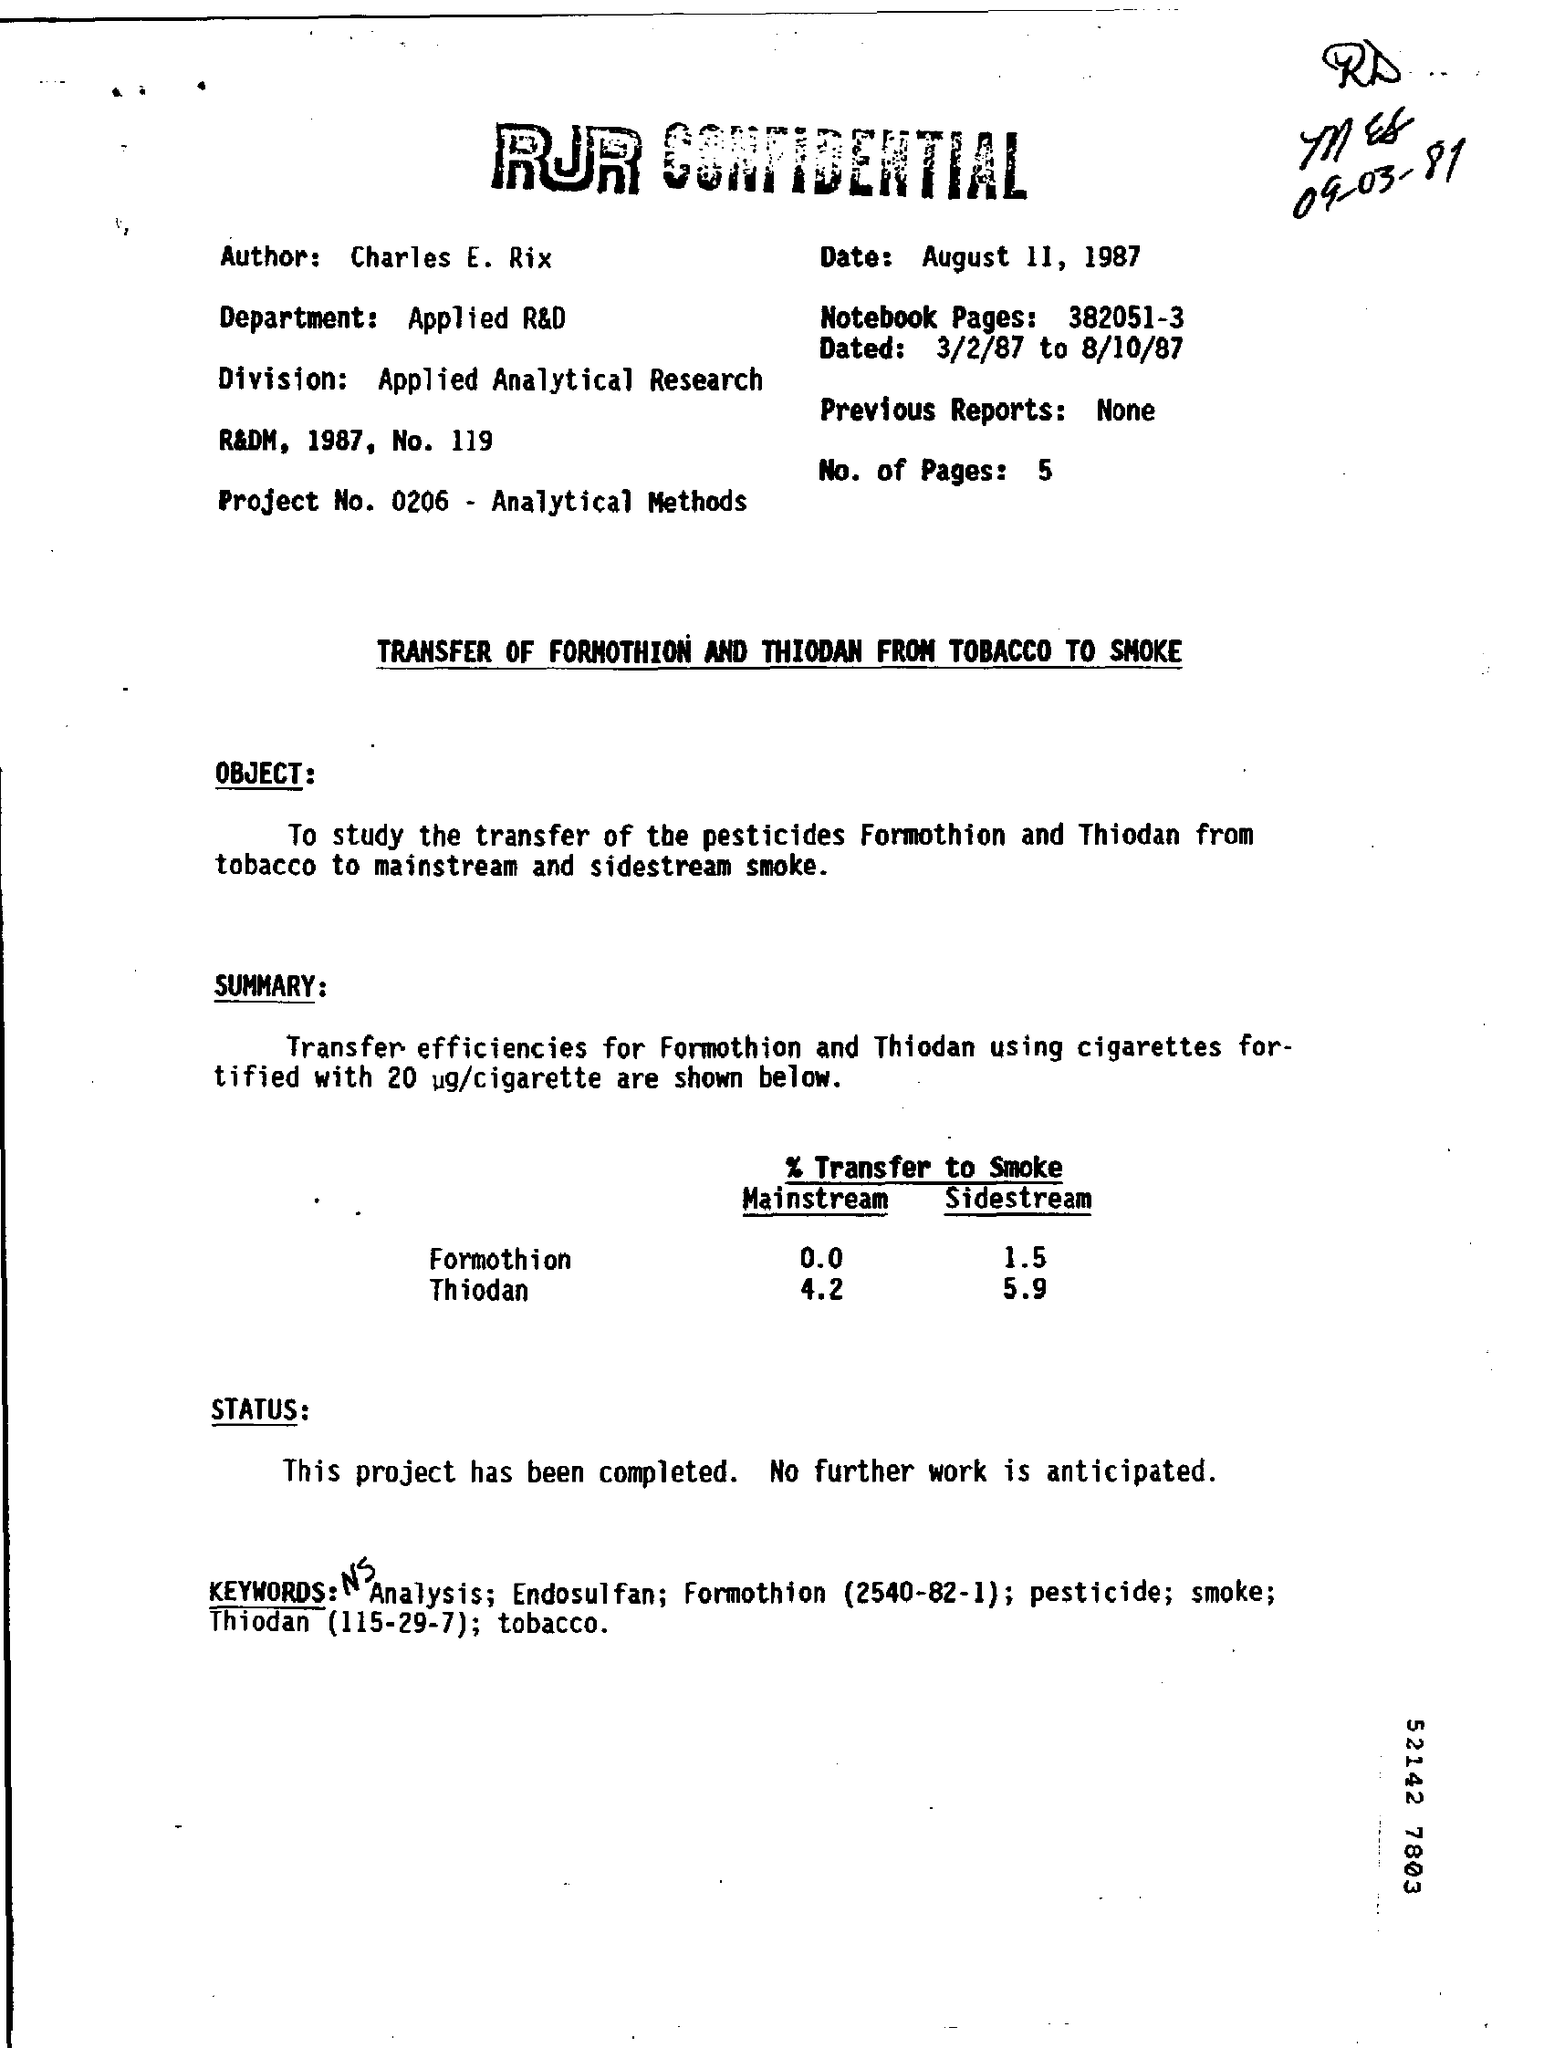Highlight a few significant elements in this photo. The Department Field displays "Applied R&D. The project number is 0206, which pertains to the topic of analytical methods. 